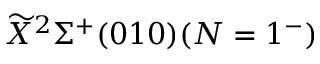<formula> <loc_0><loc_0><loc_500><loc_500>\widetilde { X ^ { 2 } \Sigma ^ { + } ( 0 1 0 ) ( N = 1 ^ { - } )</formula> 